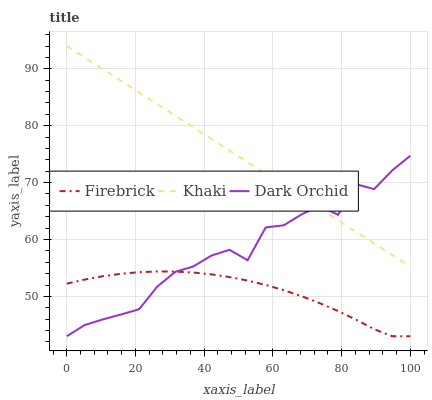Does Firebrick have the minimum area under the curve?
Answer yes or no. Yes. Does Khaki have the maximum area under the curve?
Answer yes or no. Yes. Does Dark Orchid have the minimum area under the curve?
Answer yes or no. No. Does Dark Orchid have the maximum area under the curve?
Answer yes or no. No. Is Khaki the smoothest?
Answer yes or no. Yes. Is Dark Orchid the roughest?
Answer yes or no. Yes. Is Dark Orchid the smoothest?
Answer yes or no. No. Is Khaki the roughest?
Answer yes or no. No. Does Firebrick have the lowest value?
Answer yes or no. Yes. Does Khaki have the lowest value?
Answer yes or no. No. Does Khaki have the highest value?
Answer yes or no. Yes. Does Dark Orchid have the highest value?
Answer yes or no. No. Is Firebrick less than Khaki?
Answer yes or no. Yes. Is Khaki greater than Firebrick?
Answer yes or no. Yes. Does Dark Orchid intersect Firebrick?
Answer yes or no. Yes. Is Dark Orchid less than Firebrick?
Answer yes or no. No. Is Dark Orchid greater than Firebrick?
Answer yes or no. No. Does Firebrick intersect Khaki?
Answer yes or no. No. 